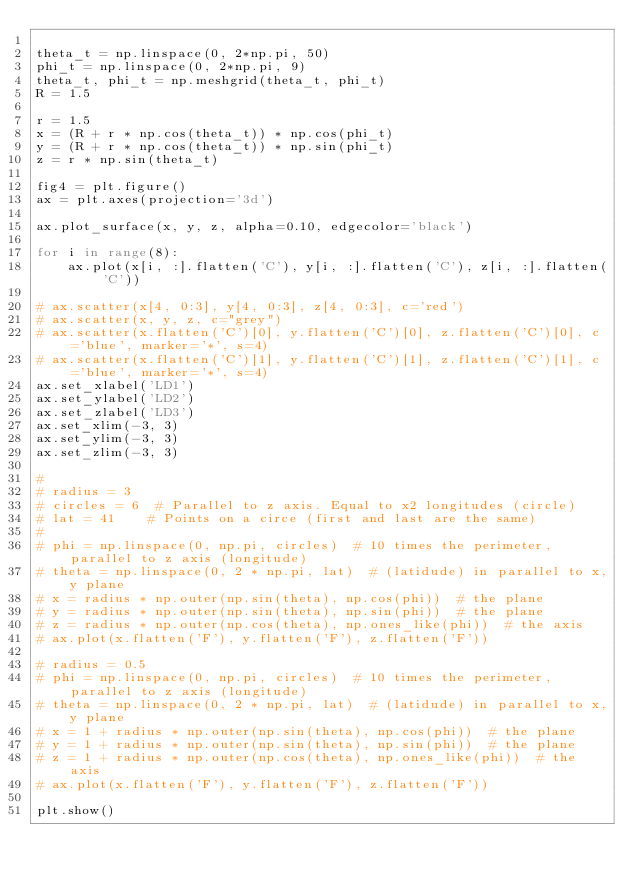<code> <loc_0><loc_0><loc_500><loc_500><_Python_>
theta_t = np.linspace(0, 2*np.pi, 50)
phi_t = np.linspace(0, 2*np.pi, 9)
theta_t, phi_t = np.meshgrid(theta_t, phi_t)
R = 1.5

r = 1.5
x = (R + r * np.cos(theta_t)) * np.cos(phi_t)
y = (R + r * np.cos(theta_t)) * np.sin(phi_t)
z = r * np.sin(theta_t)

fig4 = plt.figure()
ax = plt.axes(projection='3d')

ax.plot_surface(x, y, z, alpha=0.10, edgecolor='black')

for i in range(8):
    ax.plot(x[i, :].flatten('C'), y[i, :].flatten('C'), z[i, :].flatten('C'))

# ax.scatter(x[4, 0:3], y[4, 0:3], z[4, 0:3], c='red')
# ax.scatter(x, y, z, c="grey")
# ax.scatter(x.flatten('C')[0], y.flatten('C')[0], z.flatten('C')[0], c='blue', marker='*', s=4)
# ax.scatter(x.flatten('C')[1], y.flatten('C')[1], z.flatten('C')[1], c='blue', marker='*', s=4)
ax.set_xlabel('LD1')
ax.set_ylabel('LD2')
ax.set_zlabel('LD3')
ax.set_xlim(-3, 3)
ax.set_ylim(-3, 3)
ax.set_zlim(-3, 3)

#
# radius = 3
# circles = 6  # Parallel to z axis. Equal to x2 longitudes (circle)
# lat = 41    # Points on a circe (first and last are the same)
#
# phi = np.linspace(0, np.pi, circles)  # 10 times the perimeter, parallel to z axis (longitude)
# theta = np.linspace(0, 2 * np.pi, lat)  # (latidude) in parallel to x,y plane
# x = radius * np.outer(np.sin(theta), np.cos(phi))  # the plane
# y = radius * np.outer(np.sin(theta), np.sin(phi))  # the plane
# z = radius * np.outer(np.cos(theta), np.ones_like(phi))  # the axis
# ax.plot(x.flatten('F'), y.flatten('F'), z.flatten('F'))

# radius = 0.5
# phi = np.linspace(0, np.pi, circles)  # 10 times the perimeter, parallel to z axis (longitude)
# theta = np.linspace(0, 2 * np.pi, lat)  # (latidude) in parallel to x,y plane
# x = 1 + radius * np.outer(np.sin(theta), np.cos(phi))  # the plane
# y = 1 + radius * np.outer(np.sin(theta), np.sin(phi))  # the plane
# z = 1 + radius * np.outer(np.cos(theta), np.ones_like(phi))  # the axis
# ax.plot(x.flatten('F'), y.flatten('F'), z.flatten('F'))

plt.show()
</code> 